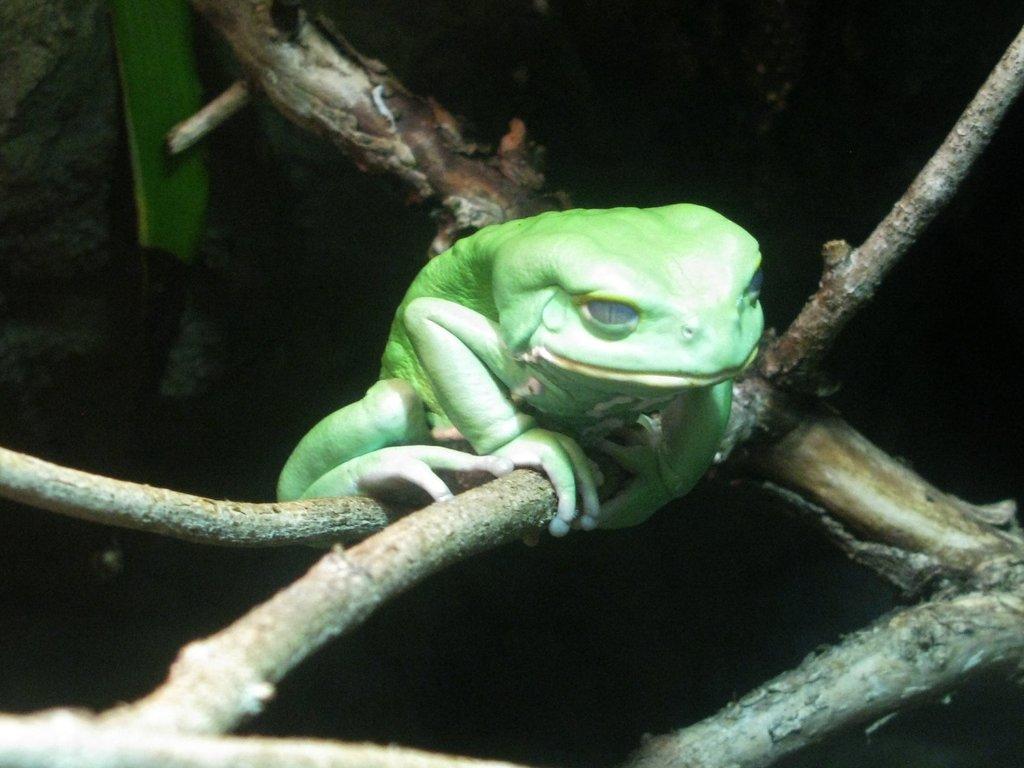How would you summarize this image in a sentence or two? This picture shows a frog on the branch of a tree, It is green in color. 